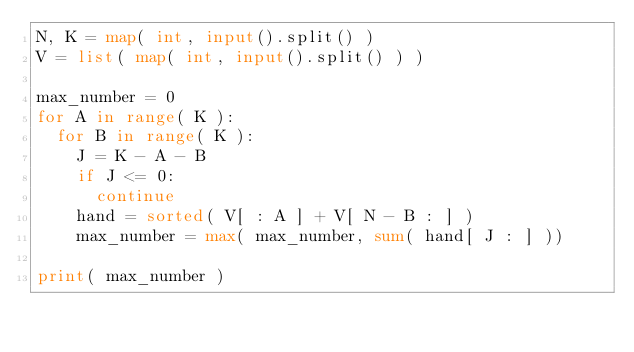<code> <loc_0><loc_0><loc_500><loc_500><_Python_>N, K = map( int, input().split() )
V = list( map( int, input().split() ) )

max_number = 0
for A in range( K ):
  for B in range( K ):
    J = K - A - B
    if J <= 0:
      continue
    hand = sorted( V[ : A ] + V[ N - B : ] )
    max_number = max( max_number, sum( hand[ J : ] ))
      
print( max_number )</code> 